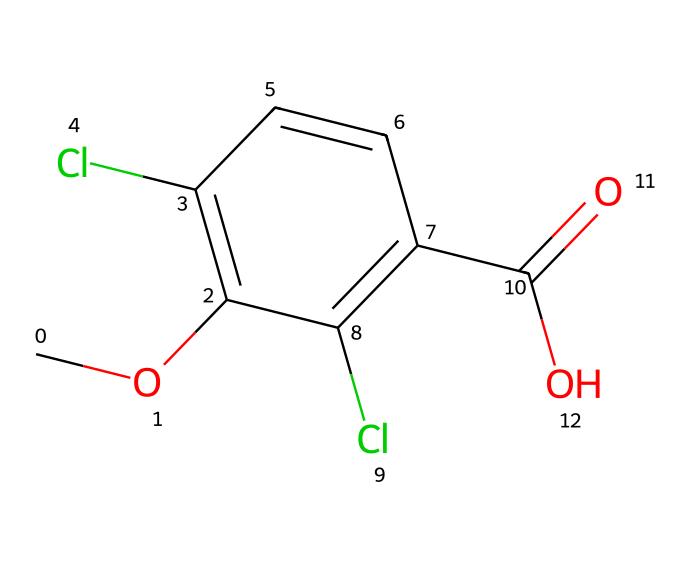What is the molecular formula of dicamba? By analyzing the SMILES representation, we can count the different atoms present: there are 10 carbon atoms (C), 9 hydrogen atoms (H), 2 chlorine atoms (Cl), and 2 oxygen atoms (O). The combined count gives a molecular formula of C10H9Cl2O3.
Answer: C10H9Cl2O3 How many rings does dicamba contain? The SMILES notation indicates a benzene-like structure with a carbon ring, which can be identified by the 'c' characters, showing aromatic carbon atoms. As there is only one set of fused 'c' characters with no other rings present, the number of rings is one.
Answer: 1 What type of functional group is present in dicamba? In the provided SMILES string, the 'C(=O)O' portion indicates a carboxylic acid functional group, which has a carbon doubly bonded to oxygen (carbonyl) and a hydroxyl (-OH) group attached to it. This is characteristic of the carboxylic acid functionality within the molecule.
Answer: carboxylic acid How many substituents are attached to the aromatic ring in dicamba? The structure shows that there are two chlorine (Cl) substituents on the aromatic ring, as denoted by the 'Cl' characters in the positions where the aromatic carbon atoms are connected. Therefore, the count of substituents is two.
Answer: 2 What role do the chlorines play in the herbicidal activity of dicamba? The chlorine atoms in dicamba provide important modifications that can influence the biological activity of the molecule. They often enhance the herbicide's effectiveness by altering its interaction with plant biochemical pathways, typically affecting its herbicidal potency.
Answer: enhance potency Is dicamba a selective herbicide? Dicamba is designed to selectively target certain plants while leaving others unharmed, making it classified as a selective herbicide. Its specificity comes from how it affects the metabolic processes in targeted plant species.
Answer: yes 